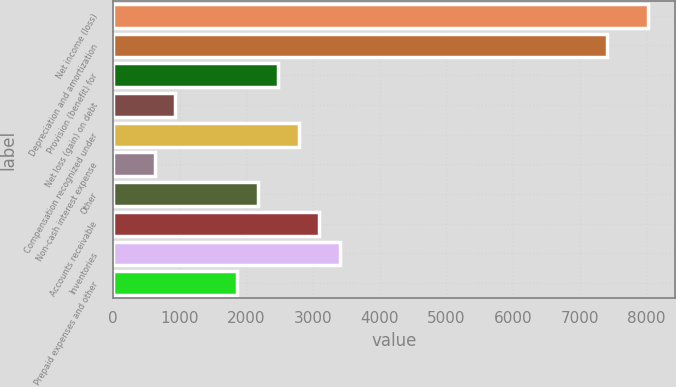Convert chart. <chart><loc_0><loc_0><loc_500><loc_500><bar_chart><fcel>Net income (loss)<fcel>Depreciation and amortization<fcel>Provision (benefit) for<fcel>Net loss (gain) on debt<fcel>Compensation recognized under<fcel>Non-cash interest expense<fcel>Other<fcel>Accounts receivable<fcel>Inventories<fcel>Prepaid expenses and other<nl><fcel>8032<fcel>7415<fcel>2479<fcel>936.5<fcel>2787.5<fcel>628<fcel>2170.5<fcel>3096<fcel>3404.5<fcel>1862<nl></chart> 